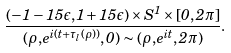<formula> <loc_0><loc_0><loc_500><loc_500>\frac { ( - 1 - 1 5 \epsilon , 1 + 1 5 \epsilon ) \times S ^ { 1 } \times [ 0 , 2 \pi ] } { ( { \rho } , e ^ { i ( t + \tau _ { l } ( { \rho } ) ) } , 0 ) \sim ( \rho , e ^ { i t } , 2 \pi ) } .</formula> 